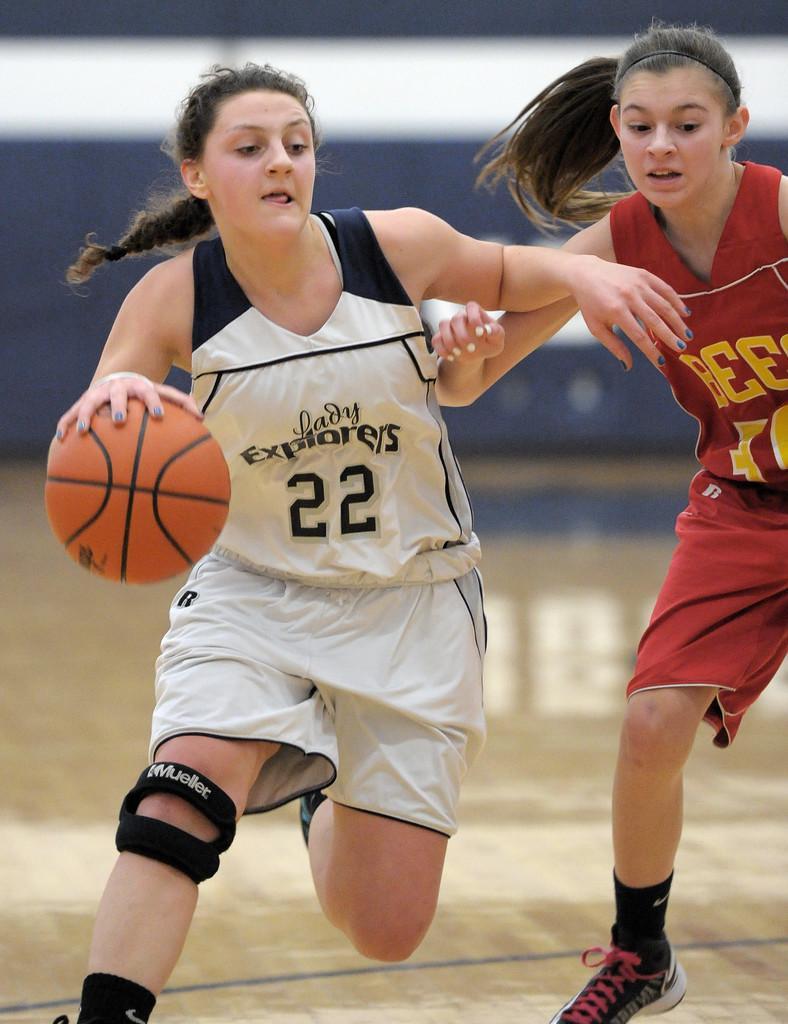Describe this image in one or two sentences. In this image I can see two persons playing game. The person in front wearing white and black dress and I can see a ball in brown color and I can see blurred background. 